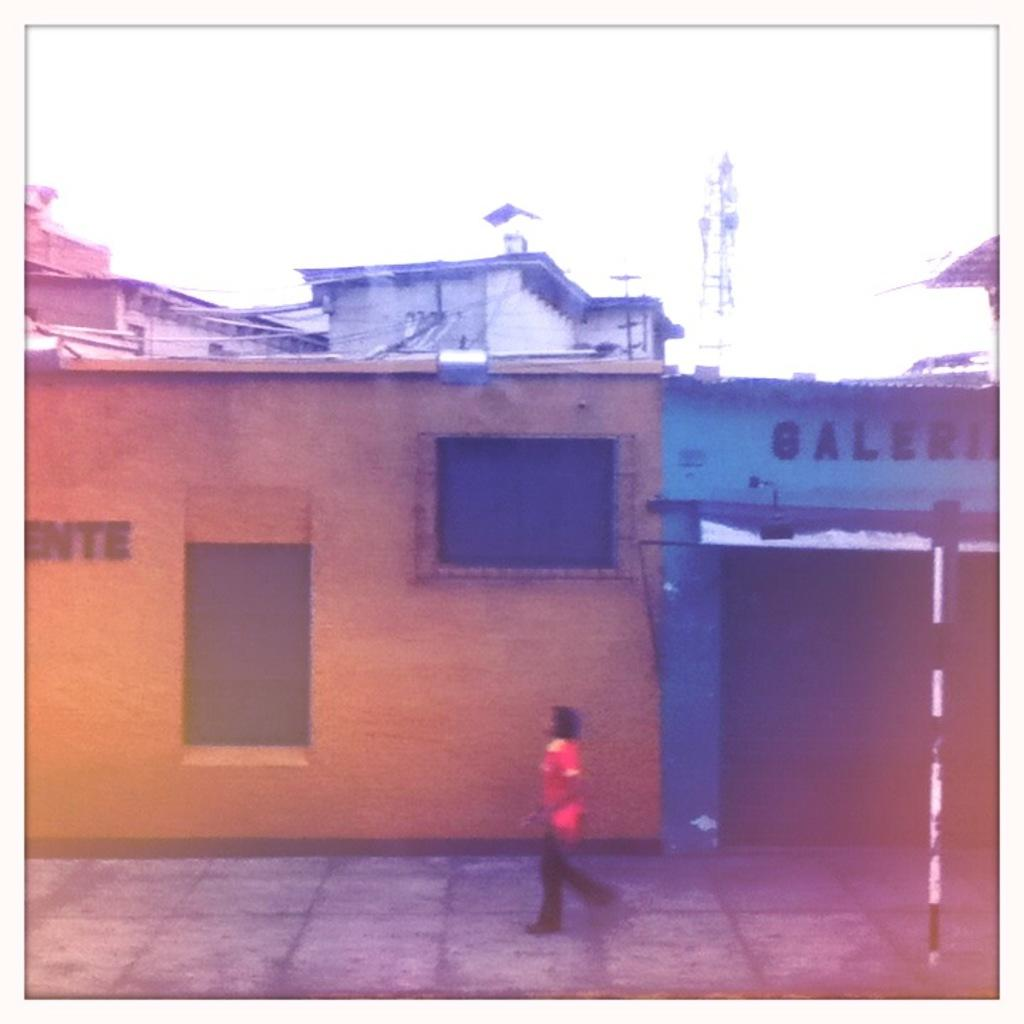What type of structures can be seen in the image? There are rooftops and stores in the image. What else is present in the image besides the structures? There are boards, a tower, and objects in the image. Can you describe the tower in the image? There is a tower in the image, but no specific details about its appearance are provided. What is the man in the image doing? There is a man walking on a pathway in the image. What type of wing is attached to the tower in the image? There is no wing attached to the tower in the image; only the tower and other structures are present. 